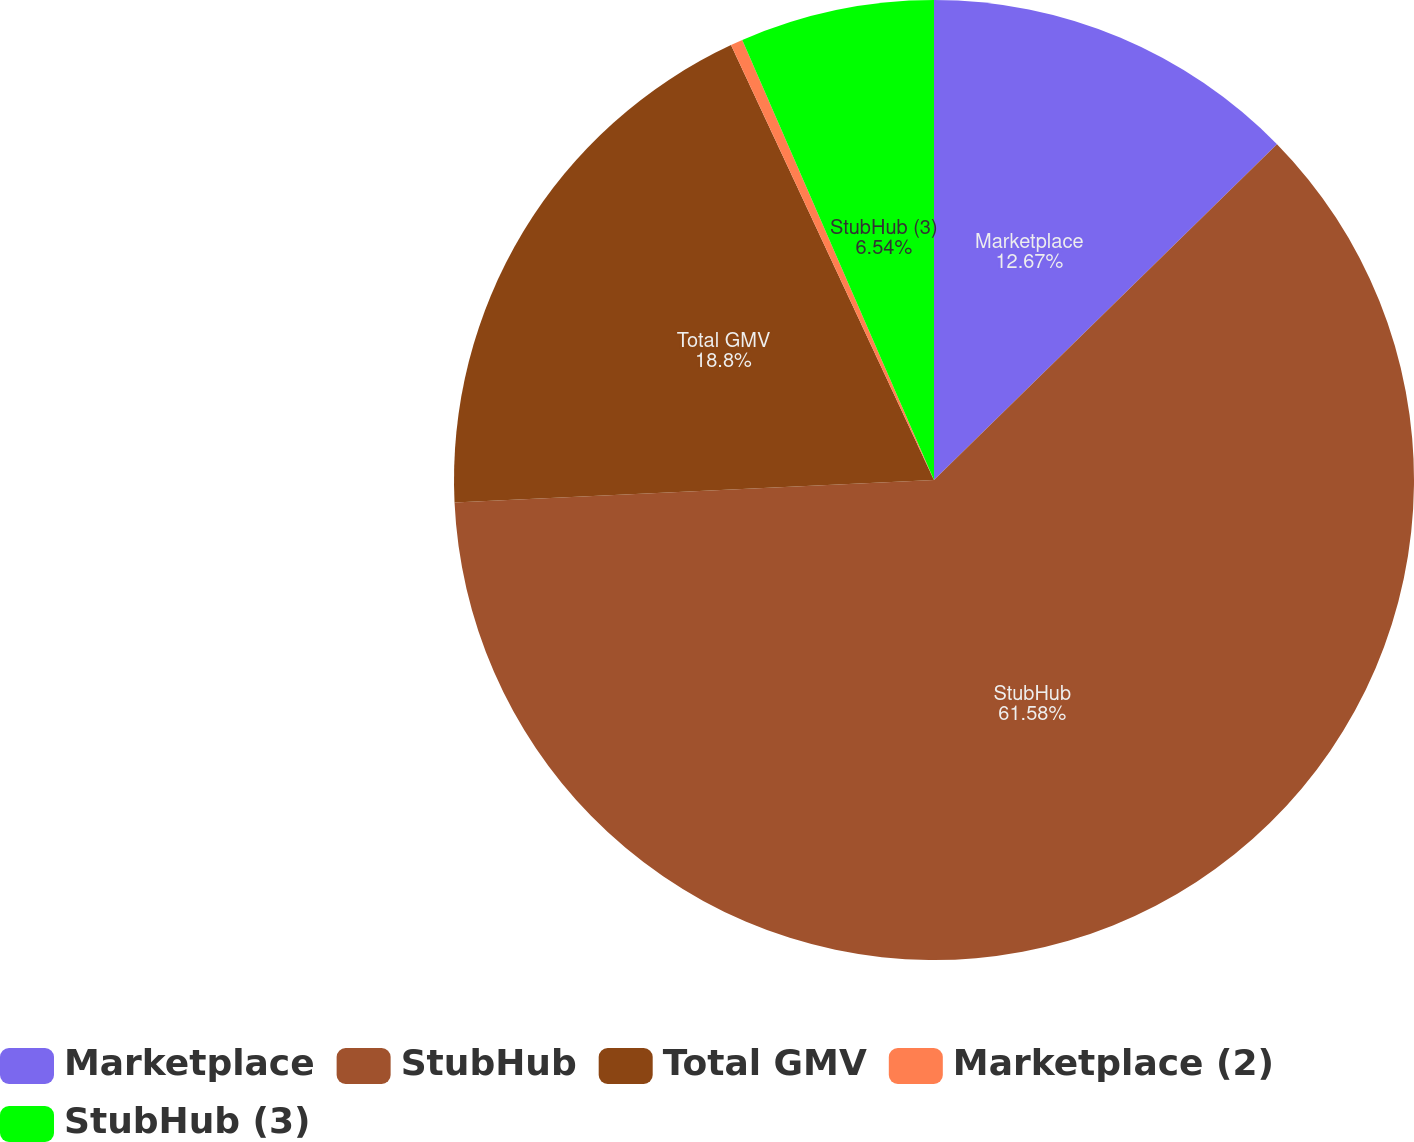Convert chart to OTSL. <chart><loc_0><loc_0><loc_500><loc_500><pie_chart><fcel>Marketplace<fcel>StubHub<fcel>Total GMV<fcel>Marketplace (2)<fcel>StubHub (3)<nl><fcel>12.67%<fcel>61.58%<fcel>18.8%<fcel>0.41%<fcel>6.54%<nl></chart> 